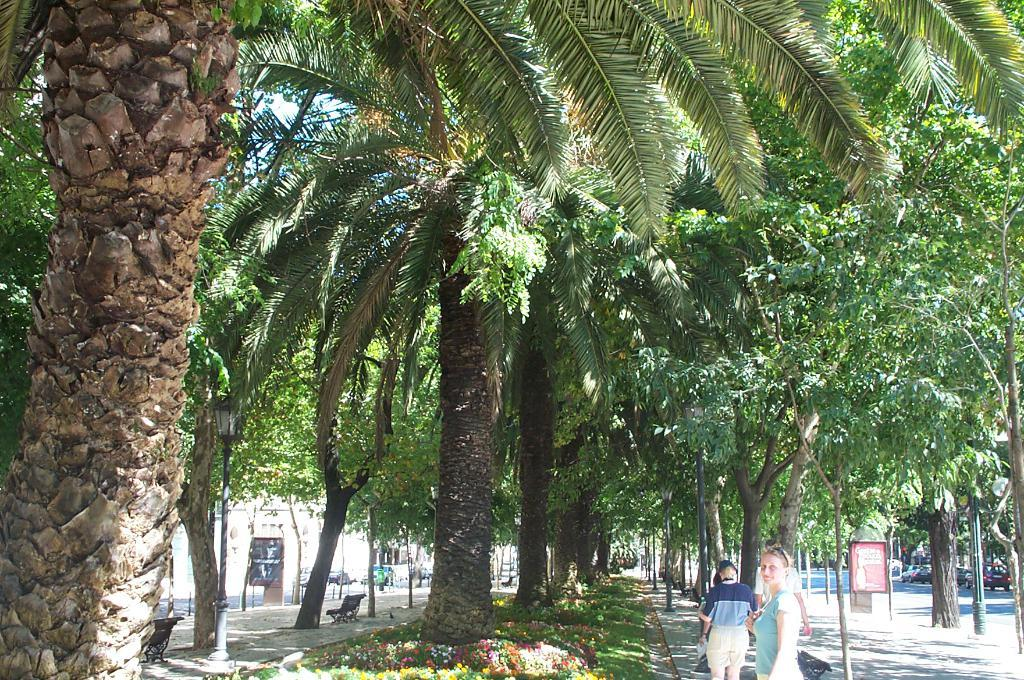What are the people in the image doing? The people in the image are standing on a path. What type of vegetation can be seen in the image? There are trees in the image. What type of seating is available in the image? There are benches in the image. What structures can be seen supporting wires or signs in the image? There are poles in the image. What type of transportation is visible in the background of the image? Cars are visible on the road in the background of the image. Can you tell me how many frogs are hopping on the path in the image? There are no frogs present in the image; it features people standing on a path with trees, benches, poles, and cars visible in the background. 